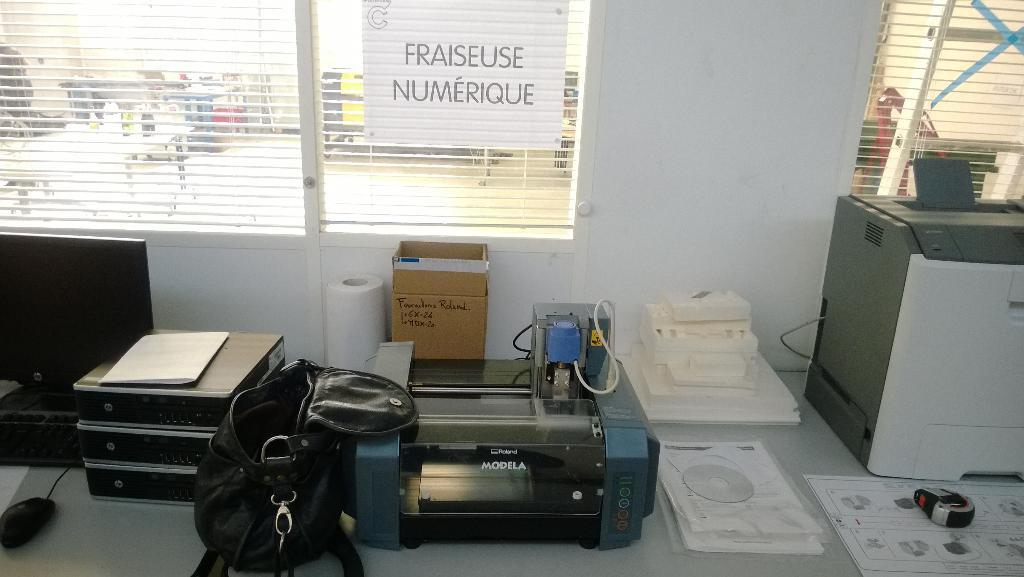What objects can be seen in the image? There is a bag, a box, a tissue roll, and a machine in the image. What is the mouse in the image used for? The mouse in the image is likely used for controlling the machine. What can be seen in the background of the image? There is a table and bottles in the background of the image. What company is responsible for the account associated with the machine in the image? There is no information about a company or account in the image, as it only shows a bag, a box, a tissue roll, a mouse, and a machine. Can you see a goldfish swimming in the background of the image? No, there is no goldfish present in the image. 